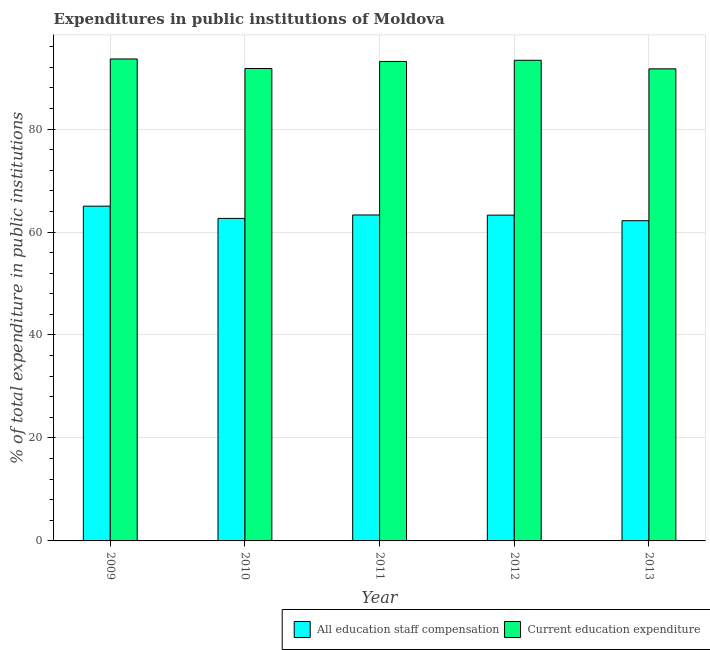How many different coloured bars are there?
Give a very brief answer. 2. How many bars are there on the 1st tick from the left?
Offer a very short reply. 2. What is the label of the 5th group of bars from the left?
Your answer should be compact. 2013. What is the expenditure in education in 2013?
Your answer should be compact. 91.69. Across all years, what is the maximum expenditure in education?
Provide a short and direct response. 93.61. Across all years, what is the minimum expenditure in staff compensation?
Your answer should be compact. 62.2. In which year was the expenditure in education minimum?
Offer a terse response. 2013. What is the total expenditure in staff compensation in the graph?
Keep it short and to the point. 316.46. What is the difference between the expenditure in education in 2009 and that in 2012?
Give a very brief answer. 0.25. What is the difference between the expenditure in education in 2013 and the expenditure in staff compensation in 2009?
Your answer should be very brief. -1.92. What is the average expenditure in staff compensation per year?
Your answer should be compact. 63.29. In how many years, is the expenditure in staff compensation greater than 52 %?
Ensure brevity in your answer.  5. What is the ratio of the expenditure in education in 2010 to that in 2012?
Your answer should be very brief. 0.98. Is the difference between the expenditure in staff compensation in 2009 and 2012 greater than the difference between the expenditure in education in 2009 and 2012?
Provide a short and direct response. No. What is the difference between the highest and the second highest expenditure in staff compensation?
Your response must be concise. 1.71. What is the difference between the highest and the lowest expenditure in education?
Your answer should be compact. 1.92. In how many years, is the expenditure in education greater than the average expenditure in education taken over all years?
Your answer should be very brief. 3. What does the 2nd bar from the left in 2012 represents?
Offer a very short reply. Current education expenditure. What does the 1st bar from the right in 2009 represents?
Provide a succinct answer. Current education expenditure. How many years are there in the graph?
Keep it short and to the point. 5. Are the values on the major ticks of Y-axis written in scientific E-notation?
Provide a succinct answer. No. Does the graph contain grids?
Your response must be concise. Yes. What is the title of the graph?
Your answer should be very brief. Expenditures in public institutions of Moldova. Does "Current US$" appear as one of the legend labels in the graph?
Your answer should be very brief. No. What is the label or title of the Y-axis?
Keep it short and to the point. % of total expenditure in public institutions. What is the % of total expenditure in public institutions of All education staff compensation in 2009?
Offer a terse response. 65.02. What is the % of total expenditure in public institutions in Current education expenditure in 2009?
Offer a very short reply. 93.61. What is the % of total expenditure in public institutions of All education staff compensation in 2010?
Offer a terse response. 62.65. What is the % of total expenditure in public institutions in Current education expenditure in 2010?
Keep it short and to the point. 91.76. What is the % of total expenditure in public institutions in All education staff compensation in 2011?
Make the answer very short. 63.31. What is the % of total expenditure in public institutions of Current education expenditure in 2011?
Keep it short and to the point. 93.13. What is the % of total expenditure in public institutions in All education staff compensation in 2012?
Provide a succinct answer. 63.28. What is the % of total expenditure in public institutions in Current education expenditure in 2012?
Offer a terse response. 93.36. What is the % of total expenditure in public institutions in All education staff compensation in 2013?
Make the answer very short. 62.2. What is the % of total expenditure in public institutions in Current education expenditure in 2013?
Make the answer very short. 91.69. Across all years, what is the maximum % of total expenditure in public institutions in All education staff compensation?
Ensure brevity in your answer.  65.02. Across all years, what is the maximum % of total expenditure in public institutions of Current education expenditure?
Your answer should be very brief. 93.61. Across all years, what is the minimum % of total expenditure in public institutions in All education staff compensation?
Make the answer very short. 62.2. Across all years, what is the minimum % of total expenditure in public institutions of Current education expenditure?
Your answer should be compact. 91.69. What is the total % of total expenditure in public institutions in All education staff compensation in the graph?
Offer a very short reply. 316.46. What is the total % of total expenditure in public institutions of Current education expenditure in the graph?
Your response must be concise. 463.55. What is the difference between the % of total expenditure in public institutions of All education staff compensation in 2009 and that in 2010?
Ensure brevity in your answer.  2.37. What is the difference between the % of total expenditure in public institutions in Current education expenditure in 2009 and that in 2010?
Your response must be concise. 1.85. What is the difference between the % of total expenditure in public institutions in All education staff compensation in 2009 and that in 2011?
Keep it short and to the point. 1.71. What is the difference between the % of total expenditure in public institutions of Current education expenditure in 2009 and that in 2011?
Offer a terse response. 0.48. What is the difference between the % of total expenditure in public institutions of All education staff compensation in 2009 and that in 2012?
Ensure brevity in your answer.  1.74. What is the difference between the % of total expenditure in public institutions in Current education expenditure in 2009 and that in 2012?
Give a very brief answer. 0.25. What is the difference between the % of total expenditure in public institutions in All education staff compensation in 2009 and that in 2013?
Give a very brief answer. 2.82. What is the difference between the % of total expenditure in public institutions in Current education expenditure in 2009 and that in 2013?
Give a very brief answer. 1.92. What is the difference between the % of total expenditure in public institutions in All education staff compensation in 2010 and that in 2011?
Keep it short and to the point. -0.66. What is the difference between the % of total expenditure in public institutions in Current education expenditure in 2010 and that in 2011?
Provide a succinct answer. -1.37. What is the difference between the % of total expenditure in public institutions in All education staff compensation in 2010 and that in 2012?
Your answer should be very brief. -0.63. What is the difference between the % of total expenditure in public institutions in Current education expenditure in 2010 and that in 2012?
Keep it short and to the point. -1.59. What is the difference between the % of total expenditure in public institutions in All education staff compensation in 2010 and that in 2013?
Ensure brevity in your answer.  0.45. What is the difference between the % of total expenditure in public institutions in Current education expenditure in 2010 and that in 2013?
Your response must be concise. 0.07. What is the difference between the % of total expenditure in public institutions of All education staff compensation in 2011 and that in 2012?
Keep it short and to the point. 0.03. What is the difference between the % of total expenditure in public institutions of Current education expenditure in 2011 and that in 2012?
Keep it short and to the point. -0.23. What is the difference between the % of total expenditure in public institutions in All education staff compensation in 2011 and that in 2013?
Your answer should be very brief. 1.11. What is the difference between the % of total expenditure in public institutions in Current education expenditure in 2011 and that in 2013?
Provide a succinct answer. 1.44. What is the difference between the % of total expenditure in public institutions of All education staff compensation in 2012 and that in 2013?
Give a very brief answer. 1.08. What is the difference between the % of total expenditure in public institutions in Current education expenditure in 2012 and that in 2013?
Give a very brief answer. 1.66. What is the difference between the % of total expenditure in public institutions in All education staff compensation in 2009 and the % of total expenditure in public institutions in Current education expenditure in 2010?
Offer a terse response. -26.74. What is the difference between the % of total expenditure in public institutions of All education staff compensation in 2009 and the % of total expenditure in public institutions of Current education expenditure in 2011?
Make the answer very short. -28.11. What is the difference between the % of total expenditure in public institutions of All education staff compensation in 2009 and the % of total expenditure in public institutions of Current education expenditure in 2012?
Give a very brief answer. -28.33. What is the difference between the % of total expenditure in public institutions of All education staff compensation in 2009 and the % of total expenditure in public institutions of Current education expenditure in 2013?
Keep it short and to the point. -26.67. What is the difference between the % of total expenditure in public institutions in All education staff compensation in 2010 and the % of total expenditure in public institutions in Current education expenditure in 2011?
Keep it short and to the point. -30.48. What is the difference between the % of total expenditure in public institutions of All education staff compensation in 2010 and the % of total expenditure in public institutions of Current education expenditure in 2012?
Provide a short and direct response. -30.71. What is the difference between the % of total expenditure in public institutions of All education staff compensation in 2010 and the % of total expenditure in public institutions of Current education expenditure in 2013?
Your answer should be very brief. -29.05. What is the difference between the % of total expenditure in public institutions in All education staff compensation in 2011 and the % of total expenditure in public institutions in Current education expenditure in 2012?
Provide a succinct answer. -30.04. What is the difference between the % of total expenditure in public institutions in All education staff compensation in 2011 and the % of total expenditure in public institutions in Current education expenditure in 2013?
Provide a short and direct response. -28.38. What is the difference between the % of total expenditure in public institutions of All education staff compensation in 2012 and the % of total expenditure in public institutions of Current education expenditure in 2013?
Offer a terse response. -28.41. What is the average % of total expenditure in public institutions of All education staff compensation per year?
Make the answer very short. 63.29. What is the average % of total expenditure in public institutions of Current education expenditure per year?
Offer a terse response. 92.71. In the year 2009, what is the difference between the % of total expenditure in public institutions of All education staff compensation and % of total expenditure in public institutions of Current education expenditure?
Your response must be concise. -28.59. In the year 2010, what is the difference between the % of total expenditure in public institutions in All education staff compensation and % of total expenditure in public institutions in Current education expenditure?
Ensure brevity in your answer.  -29.11. In the year 2011, what is the difference between the % of total expenditure in public institutions of All education staff compensation and % of total expenditure in public institutions of Current education expenditure?
Make the answer very short. -29.82. In the year 2012, what is the difference between the % of total expenditure in public institutions of All education staff compensation and % of total expenditure in public institutions of Current education expenditure?
Give a very brief answer. -30.08. In the year 2013, what is the difference between the % of total expenditure in public institutions of All education staff compensation and % of total expenditure in public institutions of Current education expenditure?
Provide a succinct answer. -29.5. What is the ratio of the % of total expenditure in public institutions of All education staff compensation in 2009 to that in 2010?
Your response must be concise. 1.04. What is the ratio of the % of total expenditure in public institutions in Current education expenditure in 2009 to that in 2010?
Ensure brevity in your answer.  1.02. What is the ratio of the % of total expenditure in public institutions of All education staff compensation in 2009 to that in 2011?
Make the answer very short. 1.03. What is the ratio of the % of total expenditure in public institutions in All education staff compensation in 2009 to that in 2012?
Provide a succinct answer. 1.03. What is the ratio of the % of total expenditure in public institutions of Current education expenditure in 2009 to that in 2012?
Provide a short and direct response. 1. What is the ratio of the % of total expenditure in public institutions of All education staff compensation in 2009 to that in 2013?
Provide a succinct answer. 1.05. What is the ratio of the % of total expenditure in public institutions of Current education expenditure in 2009 to that in 2013?
Keep it short and to the point. 1.02. What is the ratio of the % of total expenditure in public institutions in Current education expenditure in 2010 to that in 2012?
Provide a short and direct response. 0.98. What is the ratio of the % of total expenditure in public institutions of Current education expenditure in 2011 to that in 2012?
Make the answer very short. 1. What is the ratio of the % of total expenditure in public institutions of All education staff compensation in 2011 to that in 2013?
Give a very brief answer. 1.02. What is the ratio of the % of total expenditure in public institutions of Current education expenditure in 2011 to that in 2013?
Offer a terse response. 1.02. What is the ratio of the % of total expenditure in public institutions in All education staff compensation in 2012 to that in 2013?
Provide a short and direct response. 1.02. What is the ratio of the % of total expenditure in public institutions of Current education expenditure in 2012 to that in 2013?
Ensure brevity in your answer.  1.02. What is the difference between the highest and the second highest % of total expenditure in public institutions in All education staff compensation?
Your answer should be compact. 1.71. What is the difference between the highest and the second highest % of total expenditure in public institutions of Current education expenditure?
Offer a terse response. 0.25. What is the difference between the highest and the lowest % of total expenditure in public institutions in All education staff compensation?
Your response must be concise. 2.82. What is the difference between the highest and the lowest % of total expenditure in public institutions in Current education expenditure?
Ensure brevity in your answer.  1.92. 